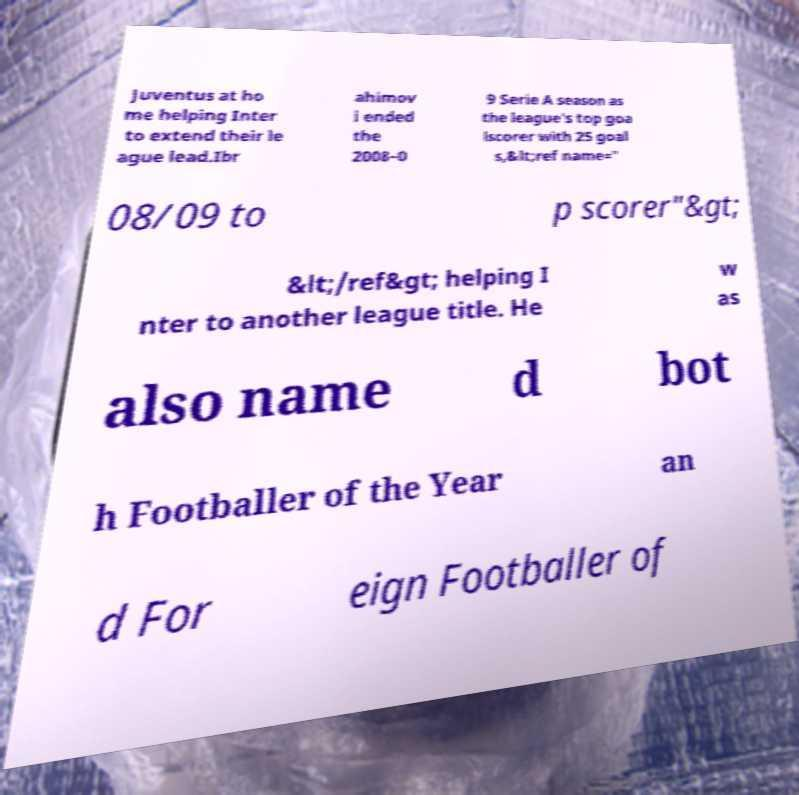Please read and relay the text visible in this image. What does it say? Juventus at ho me helping Inter to extend their le ague lead.Ibr ahimov i ended the 2008–0 9 Serie A season as the league's top goa lscorer with 25 goal s,&lt;ref name=" 08/09 to p scorer"&gt; &lt;/ref&gt; helping I nter to another league title. He w as also name d bot h Footballer of the Year an d For eign Footballer of 